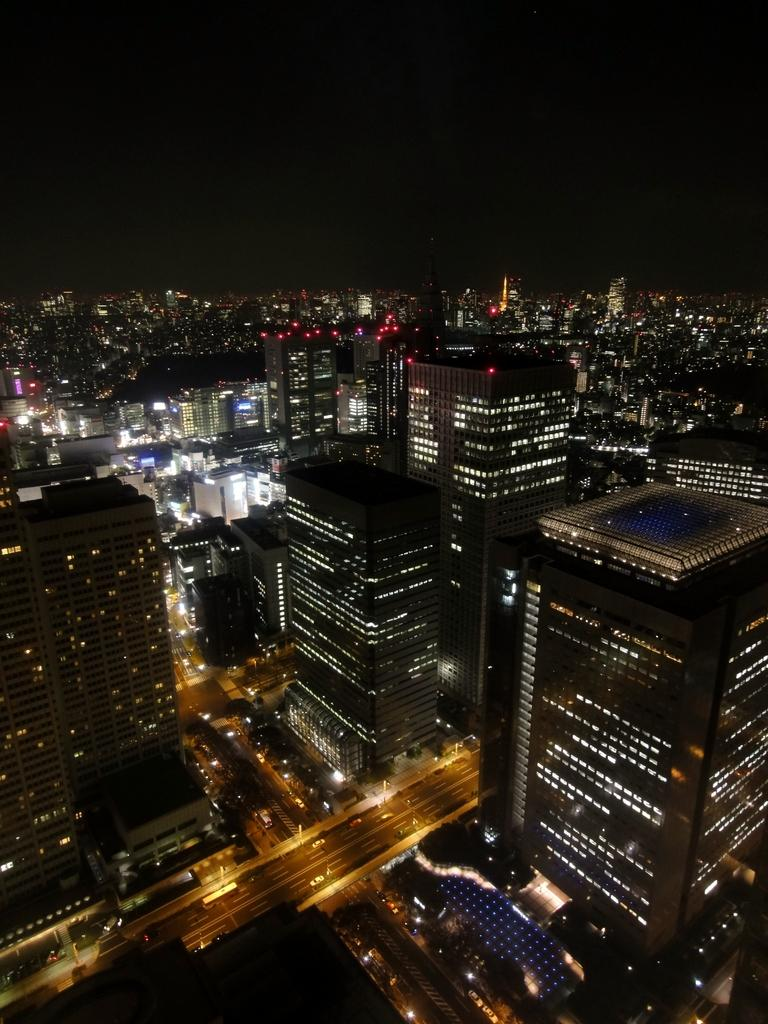What type of structures can be seen in the image? There are buildings in the image. What can be seen illuminating the scene in the image? There are lights visible in the image. What is the main pathway in the image? There is a road in the image. What is moving along the road in the image? There are vehicles on the road. What is visible in the background of the image? The sky is visible in the background of the image. Are there any bells ringing in the field in the image? There is no field or bells present in the image; it features buildings, lights, a road, vehicles, and the sky. Can you see a bat flying in the sky in the image? There is no bat visible in the sky in the image; only lights and the sky are present. 